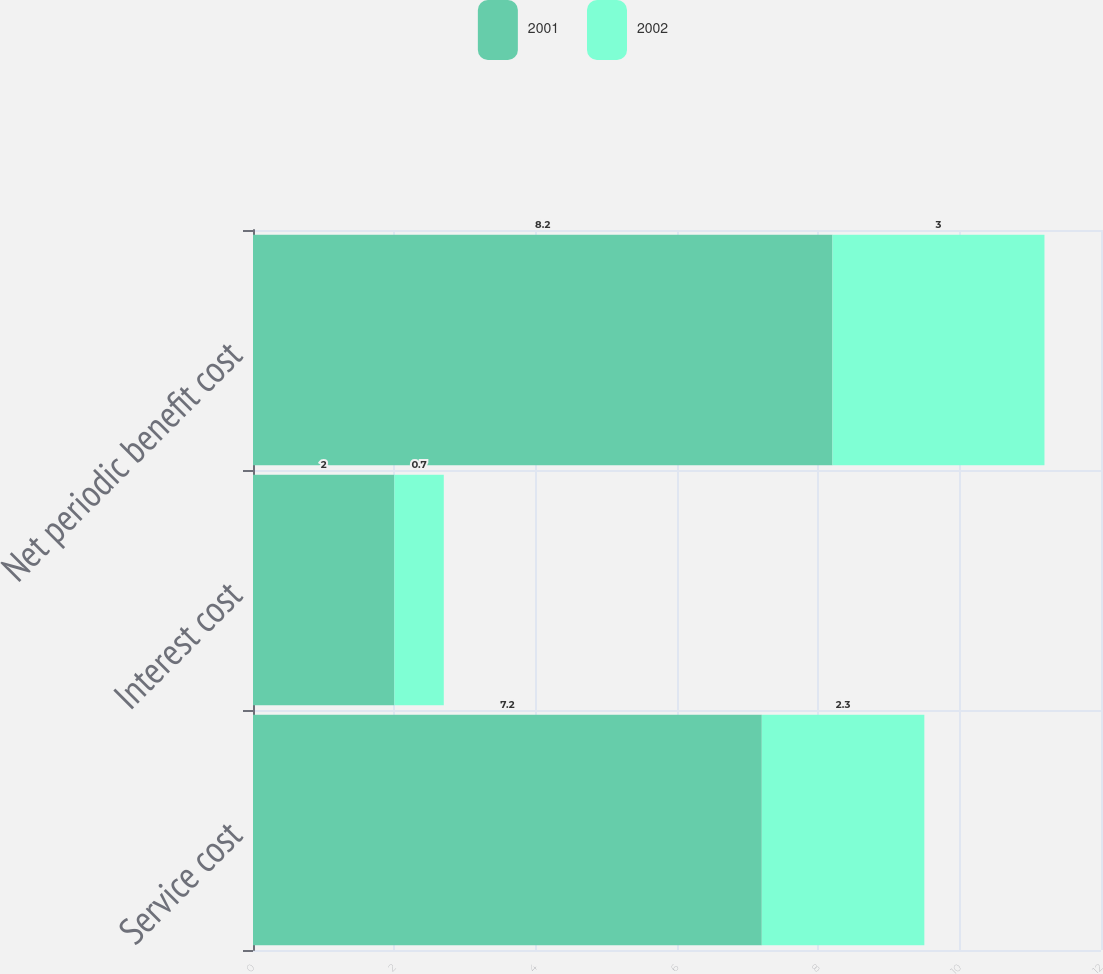<chart> <loc_0><loc_0><loc_500><loc_500><stacked_bar_chart><ecel><fcel>Service cost<fcel>Interest cost<fcel>Net periodic benefit cost<nl><fcel>2001<fcel>7.2<fcel>2<fcel>8.2<nl><fcel>2002<fcel>2.3<fcel>0.7<fcel>3<nl></chart> 